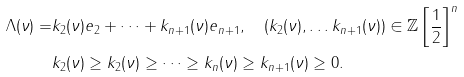Convert formula to latex. <formula><loc_0><loc_0><loc_500><loc_500>\Lambda ( \nu ) = & k _ { 2 } ( \nu ) e _ { 2 } + \dots + k _ { n + 1 } ( \nu ) e _ { n + 1 } , \quad ( k _ { 2 } ( \nu ) , \dots k _ { n + 1 } ( \nu ) ) \in { { \mathbb { Z } } \left [ \frac { 1 } { 2 } \right ] } ^ { n } \\ & k _ { 2 } ( \nu ) \geq k _ { 2 } ( \nu ) \geq \dots \geq k _ { n } ( \nu ) \geq k _ { n + 1 } ( \nu ) \geq 0 .</formula> 